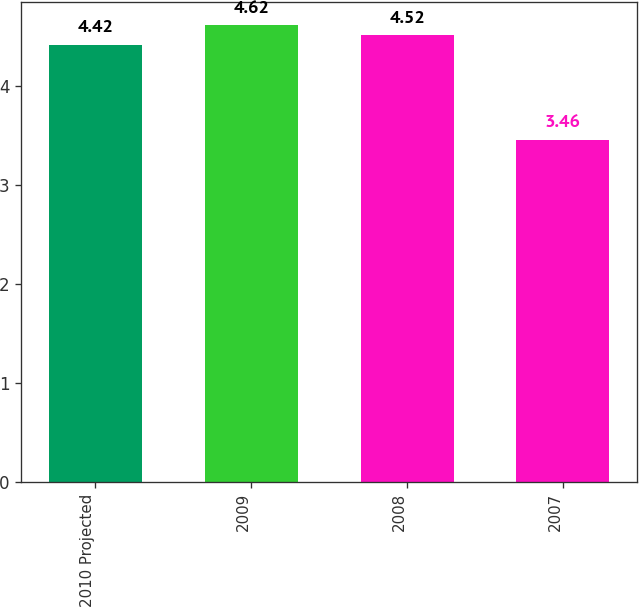Convert chart. <chart><loc_0><loc_0><loc_500><loc_500><bar_chart><fcel>2010 Projected<fcel>2009<fcel>2008<fcel>2007<nl><fcel>4.42<fcel>4.62<fcel>4.52<fcel>3.46<nl></chart> 